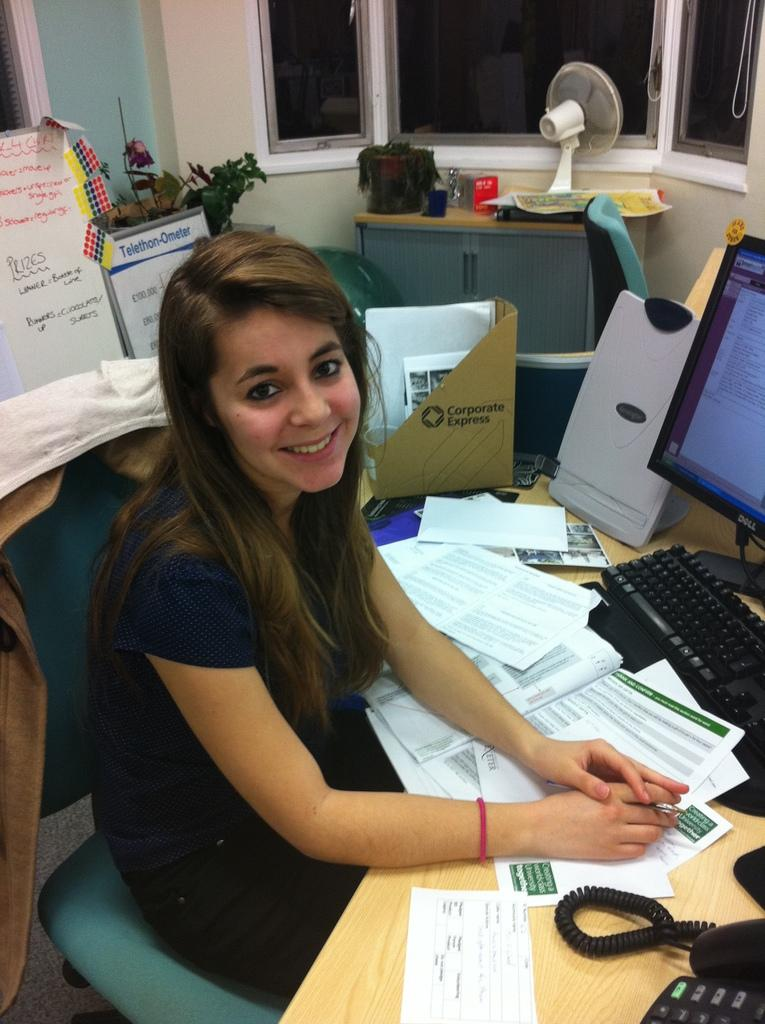<image>
Render a clear and concise summary of the photo. Girl posing for a photo with a box in the back that says "Corporate Express". 